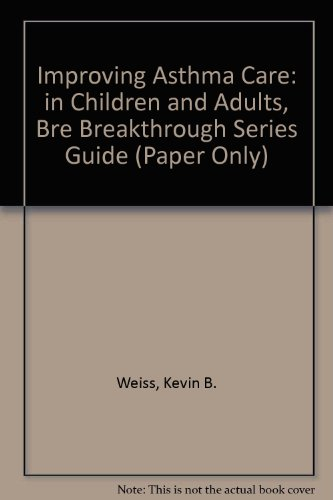What is the genre of this book? The genre of this book is primarily in the field of health care, focusing on asthma management, although it is grouped under 'Health, Fitness & Dieting'. 